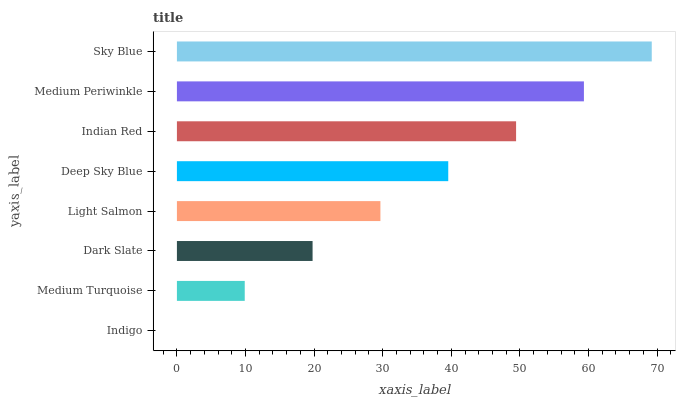Is Indigo the minimum?
Answer yes or no. Yes. Is Sky Blue the maximum?
Answer yes or no. Yes. Is Medium Turquoise the minimum?
Answer yes or no. No. Is Medium Turquoise the maximum?
Answer yes or no. No. Is Medium Turquoise greater than Indigo?
Answer yes or no. Yes. Is Indigo less than Medium Turquoise?
Answer yes or no. Yes. Is Indigo greater than Medium Turquoise?
Answer yes or no. No. Is Medium Turquoise less than Indigo?
Answer yes or no. No. Is Deep Sky Blue the high median?
Answer yes or no. Yes. Is Light Salmon the low median?
Answer yes or no. Yes. Is Medium Turquoise the high median?
Answer yes or no. No. Is Medium Periwinkle the low median?
Answer yes or no. No. 